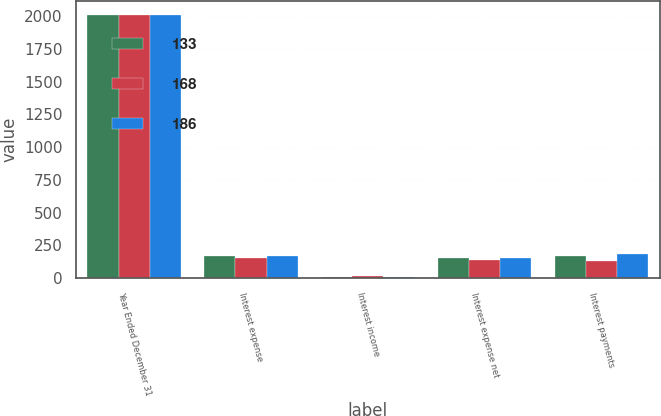Convert chart to OTSL. <chart><loc_0><loc_0><loc_500><loc_500><stacked_bar_chart><ecel><fcel>Year Ended December 31<fcel>Interest expense<fcel>Interest income<fcel>Interest expense net<fcel>Interest payments<nl><fcel>133<fcel>2010<fcel>167<fcel>10<fcel>157<fcel>168<nl><fcel>168<fcel>2011<fcel>155<fcel>14<fcel>141<fcel>133<nl><fcel>186<fcel>2012<fcel>168<fcel>12<fcel>156<fcel>186<nl></chart> 